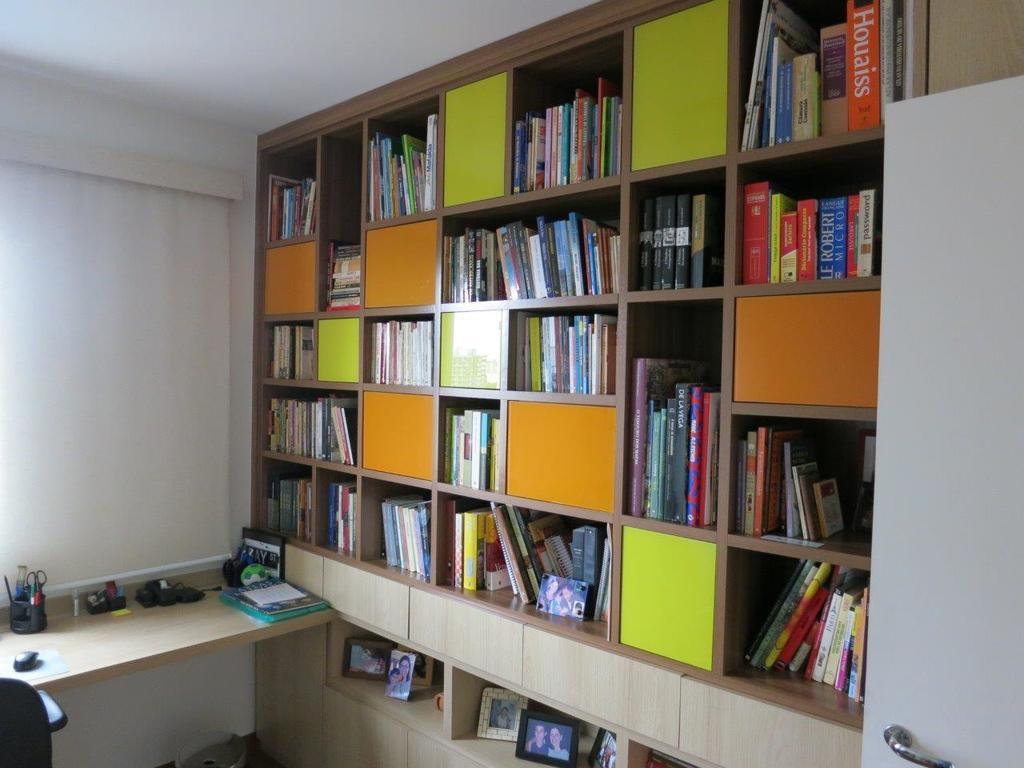<image>
Render a clear and concise summary of the photo. A large red book titled Houaiss is shelved on a bookcase with many other books. 